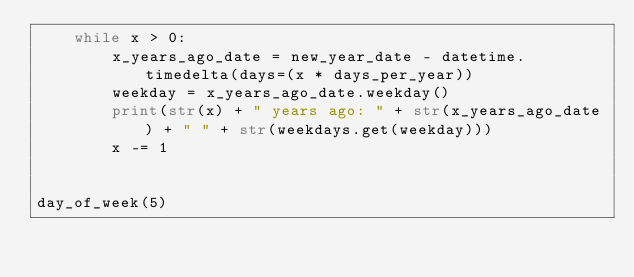Convert code to text. <code><loc_0><loc_0><loc_500><loc_500><_Python_>    while x > 0:
        x_years_ago_date = new_year_date - datetime.timedelta(days=(x * days_per_year))
        weekday = x_years_ago_date.weekday()
        print(str(x) + " years ago: " + str(x_years_ago_date) + " " + str(weekdays.get(weekday)))
        x -= 1


day_of_week(5)
</code> 